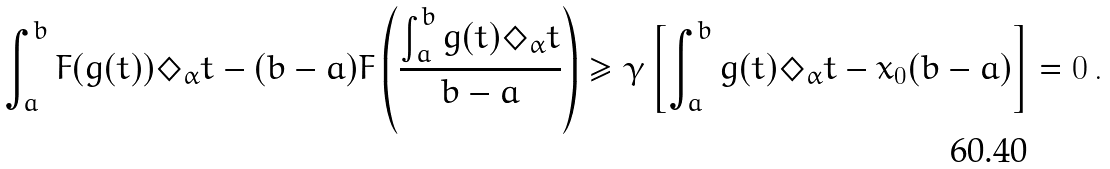Convert formula to latex. <formula><loc_0><loc_0><loc_500><loc_500>\int _ { a } ^ { b } F ( g ( t ) ) \Diamond _ { \alpha } t - ( b - a ) F \left ( \frac { \int _ { a } ^ { b } g ( t ) \Diamond _ { \alpha } t } { b - a } \right ) \geq \gamma \left [ \int _ { a } ^ { b } g ( t ) \Diamond _ { \alpha } t - x _ { 0 } ( b - a ) \right ] = 0 \, .</formula> 